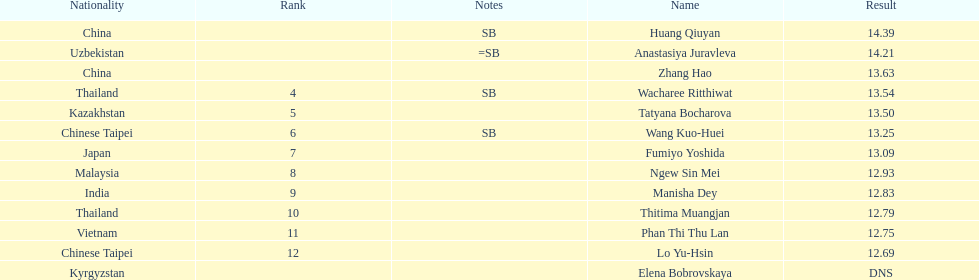Which country had the most competitors ranked in the top three in the event? China. 